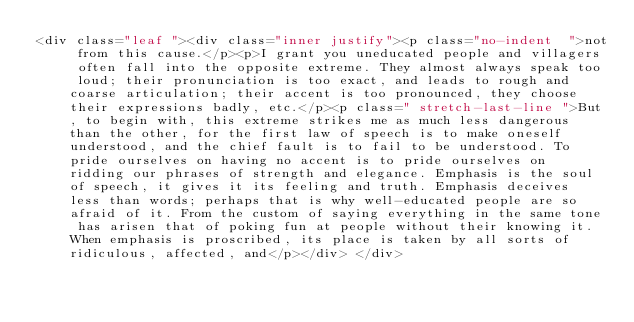<code> <loc_0><loc_0><loc_500><loc_500><_HTML_><div class="leaf "><div class="inner justify"><p class="no-indent  ">not from this cause.</p><p>I grant you uneducated people and villagers often fall into the opposite extreme. They almost always speak too loud; their pronunciation is too exact, and leads to rough and coarse articulation; their accent is too pronounced, they choose their expressions badly, etc.</p><p class=" stretch-last-line ">But, to begin with, this extreme strikes me as much less dangerous than the other, for the first law of speech is to make oneself understood, and the chief fault is to fail to be understood. To pride ourselves on having no accent is to pride ourselves on ridding our phrases of strength and elegance. Emphasis is the soul of speech, it gives it its feeling and truth. Emphasis deceives less than words; perhaps that is why well-educated people are so afraid of it. From the custom of saying everything in the same tone has arisen that of poking fun at people without their knowing it. When emphasis is proscribed, its place is taken by all sorts of ridiculous, affected, and</p></div> </div></code> 